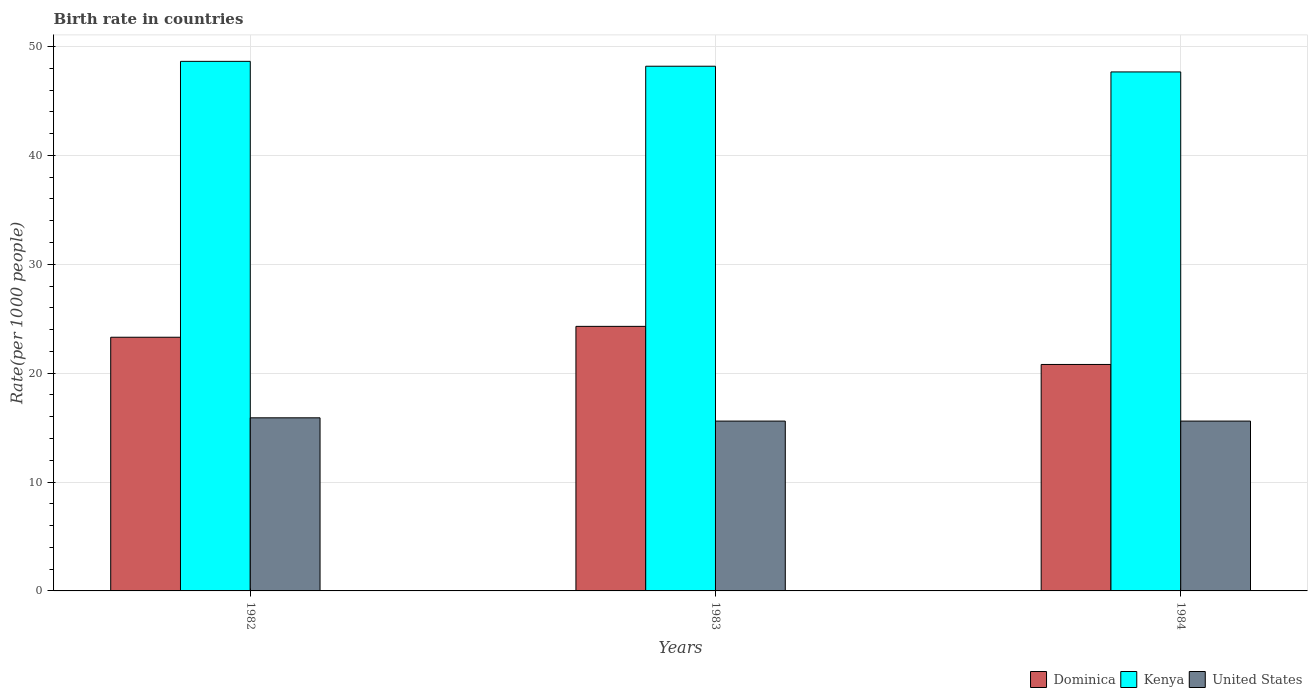Are the number of bars per tick equal to the number of legend labels?
Ensure brevity in your answer.  Yes. How many bars are there on the 1st tick from the left?
Make the answer very short. 3. What is the birth rate in Kenya in 1983?
Provide a succinct answer. 48.19. Across all years, what is the minimum birth rate in Dominica?
Provide a short and direct response. 20.8. In which year was the birth rate in Kenya maximum?
Provide a short and direct response. 1982. What is the total birth rate in Kenya in the graph?
Ensure brevity in your answer.  144.5. What is the difference between the birth rate in Kenya in 1982 and that in 1983?
Make the answer very short. 0.45. What is the average birth rate in Dominica per year?
Give a very brief answer. 22.8. In the year 1984, what is the difference between the birth rate in United States and birth rate in Dominica?
Your answer should be very brief. -5.2. In how many years, is the birth rate in Kenya greater than 34?
Your answer should be compact. 3. What is the ratio of the birth rate in Kenya in 1982 to that in 1984?
Keep it short and to the point. 1.02. What is the difference between the highest and the second highest birth rate in Kenya?
Make the answer very short. 0.45. What is the difference between the highest and the lowest birth rate in United States?
Keep it short and to the point. 0.3. What does the 1st bar from the left in 1983 represents?
Ensure brevity in your answer.  Dominica. What does the 1st bar from the right in 1983 represents?
Ensure brevity in your answer.  United States. Is it the case that in every year, the sum of the birth rate in Kenya and birth rate in United States is greater than the birth rate in Dominica?
Ensure brevity in your answer.  Yes. How many bars are there?
Offer a terse response. 9. How many years are there in the graph?
Give a very brief answer. 3. Where does the legend appear in the graph?
Make the answer very short. Bottom right. How many legend labels are there?
Give a very brief answer. 3. How are the legend labels stacked?
Provide a succinct answer. Horizontal. What is the title of the graph?
Provide a succinct answer. Birth rate in countries. What is the label or title of the Y-axis?
Provide a short and direct response. Rate(per 1000 people). What is the Rate(per 1000 people) of Dominica in 1982?
Give a very brief answer. 23.3. What is the Rate(per 1000 people) in Kenya in 1982?
Ensure brevity in your answer.  48.64. What is the Rate(per 1000 people) in Dominica in 1983?
Keep it short and to the point. 24.3. What is the Rate(per 1000 people) of Kenya in 1983?
Provide a succinct answer. 48.19. What is the Rate(per 1000 people) in Dominica in 1984?
Your answer should be very brief. 20.8. What is the Rate(per 1000 people) in Kenya in 1984?
Provide a short and direct response. 47.67. What is the Rate(per 1000 people) of United States in 1984?
Ensure brevity in your answer.  15.6. Across all years, what is the maximum Rate(per 1000 people) of Dominica?
Your answer should be compact. 24.3. Across all years, what is the maximum Rate(per 1000 people) in Kenya?
Offer a very short reply. 48.64. Across all years, what is the maximum Rate(per 1000 people) of United States?
Provide a succinct answer. 15.9. Across all years, what is the minimum Rate(per 1000 people) of Dominica?
Provide a short and direct response. 20.8. Across all years, what is the minimum Rate(per 1000 people) of Kenya?
Offer a very short reply. 47.67. What is the total Rate(per 1000 people) in Dominica in the graph?
Ensure brevity in your answer.  68.4. What is the total Rate(per 1000 people) of Kenya in the graph?
Offer a terse response. 144.5. What is the total Rate(per 1000 people) of United States in the graph?
Provide a short and direct response. 47.1. What is the difference between the Rate(per 1000 people) of Dominica in 1982 and that in 1983?
Your response must be concise. -1. What is the difference between the Rate(per 1000 people) of Kenya in 1982 and that in 1983?
Your response must be concise. 0.45. What is the difference between the Rate(per 1000 people) of United States in 1982 and that in 1983?
Your response must be concise. 0.3. What is the difference between the Rate(per 1000 people) of Kenya in 1982 and that in 1984?
Provide a succinct answer. 0.97. What is the difference between the Rate(per 1000 people) of Kenya in 1983 and that in 1984?
Make the answer very short. 0.52. What is the difference between the Rate(per 1000 people) of Dominica in 1982 and the Rate(per 1000 people) of Kenya in 1983?
Your answer should be compact. -24.89. What is the difference between the Rate(per 1000 people) in Dominica in 1982 and the Rate(per 1000 people) in United States in 1983?
Ensure brevity in your answer.  7.7. What is the difference between the Rate(per 1000 people) of Kenya in 1982 and the Rate(per 1000 people) of United States in 1983?
Make the answer very short. 33.04. What is the difference between the Rate(per 1000 people) of Dominica in 1982 and the Rate(per 1000 people) of Kenya in 1984?
Your response must be concise. -24.37. What is the difference between the Rate(per 1000 people) in Kenya in 1982 and the Rate(per 1000 people) in United States in 1984?
Offer a terse response. 33.04. What is the difference between the Rate(per 1000 people) in Dominica in 1983 and the Rate(per 1000 people) in Kenya in 1984?
Provide a succinct answer. -23.37. What is the difference between the Rate(per 1000 people) of Kenya in 1983 and the Rate(per 1000 people) of United States in 1984?
Provide a succinct answer. 32.59. What is the average Rate(per 1000 people) in Dominica per year?
Your response must be concise. 22.8. What is the average Rate(per 1000 people) of Kenya per year?
Make the answer very short. 48.17. What is the average Rate(per 1000 people) of United States per year?
Provide a succinct answer. 15.7. In the year 1982, what is the difference between the Rate(per 1000 people) of Dominica and Rate(per 1000 people) of Kenya?
Keep it short and to the point. -25.34. In the year 1982, what is the difference between the Rate(per 1000 people) of Dominica and Rate(per 1000 people) of United States?
Make the answer very short. 7.4. In the year 1982, what is the difference between the Rate(per 1000 people) in Kenya and Rate(per 1000 people) in United States?
Offer a very short reply. 32.74. In the year 1983, what is the difference between the Rate(per 1000 people) of Dominica and Rate(per 1000 people) of Kenya?
Offer a terse response. -23.89. In the year 1983, what is the difference between the Rate(per 1000 people) of Dominica and Rate(per 1000 people) of United States?
Offer a very short reply. 8.7. In the year 1983, what is the difference between the Rate(per 1000 people) in Kenya and Rate(per 1000 people) in United States?
Make the answer very short. 32.59. In the year 1984, what is the difference between the Rate(per 1000 people) of Dominica and Rate(per 1000 people) of Kenya?
Your answer should be compact. -26.87. In the year 1984, what is the difference between the Rate(per 1000 people) in Kenya and Rate(per 1000 people) in United States?
Your answer should be very brief. 32.07. What is the ratio of the Rate(per 1000 people) of Dominica in 1982 to that in 1983?
Ensure brevity in your answer.  0.96. What is the ratio of the Rate(per 1000 people) of Kenya in 1982 to that in 1983?
Keep it short and to the point. 1.01. What is the ratio of the Rate(per 1000 people) of United States in 1982 to that in 1983?
Keep it short and to the point. 1.02. What is the ratio of the Rate(per 1000 people) of Dominica in 1982 to that in 1984?
Your response must be concise. 1.12. What is the ratio of the Rate(per 1000 people) in Kenya in 1982 to that in 1984?
Your response must be concise. 1.02. What is the ratio of the Rate(per 1000 people) in United States in 1982 to that in 1984?
Your answer should be compact. 1.02. What is the ratio of the Rate(per 1000 people) of Dominica in 1983 to that in 1984?
Offer a terse response. 1.17. What is the ratio of the Rate(per 1000 people) of Kenya in 1983 to that in 1984?
Offer a terse response. 1.01. What is the difference between the highest and the second highest Rate(per 1000 people) of Dominica?
Offer a very short reply. 1. What is the difference between the highest and the second highest Rate(per 1000 people) of Kenya?
Make the answer very short. 0.45. What is the difference between the highest and the second highest Rate(per 1000 people) of United States?
Offer a terse response. 0.3. What is the difference between the highest and the lowest Rate(per 1000 people) of Kenya?
Ensure brevity in your answer.  0.97. 